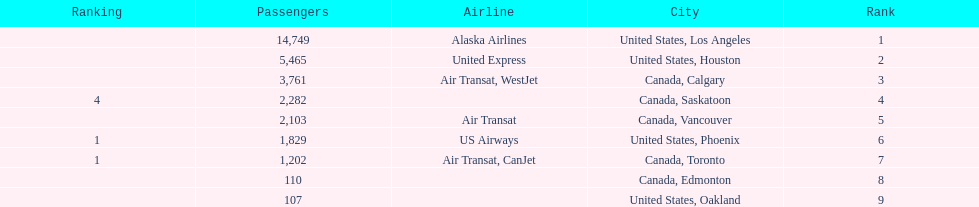Los angeles and what other city had about 19,000 passenger combined Canada, Calgary. 